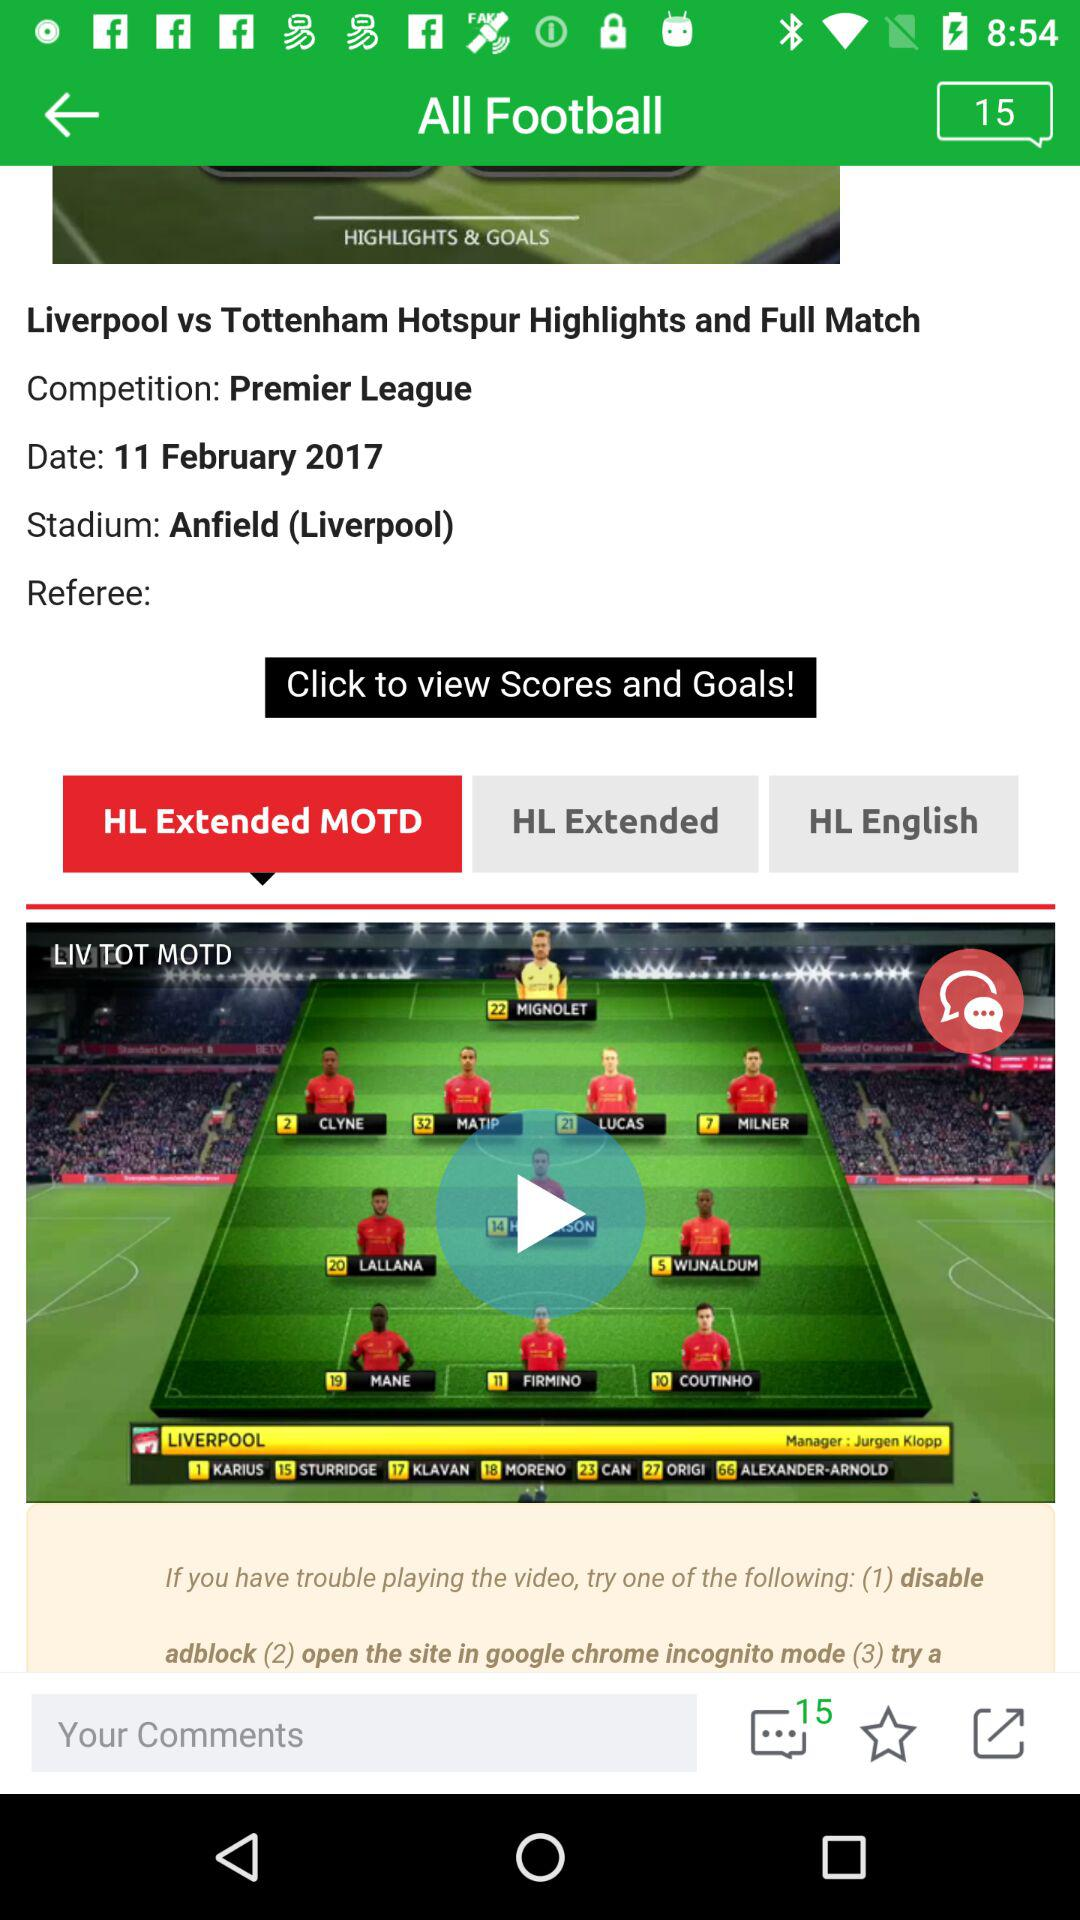What is the selected tab? The selected tab is "HL Extended MOTD". 